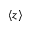<formula> <loc_0><loc_0><loc_500><loc_500>\langle z \rangle</formula> 